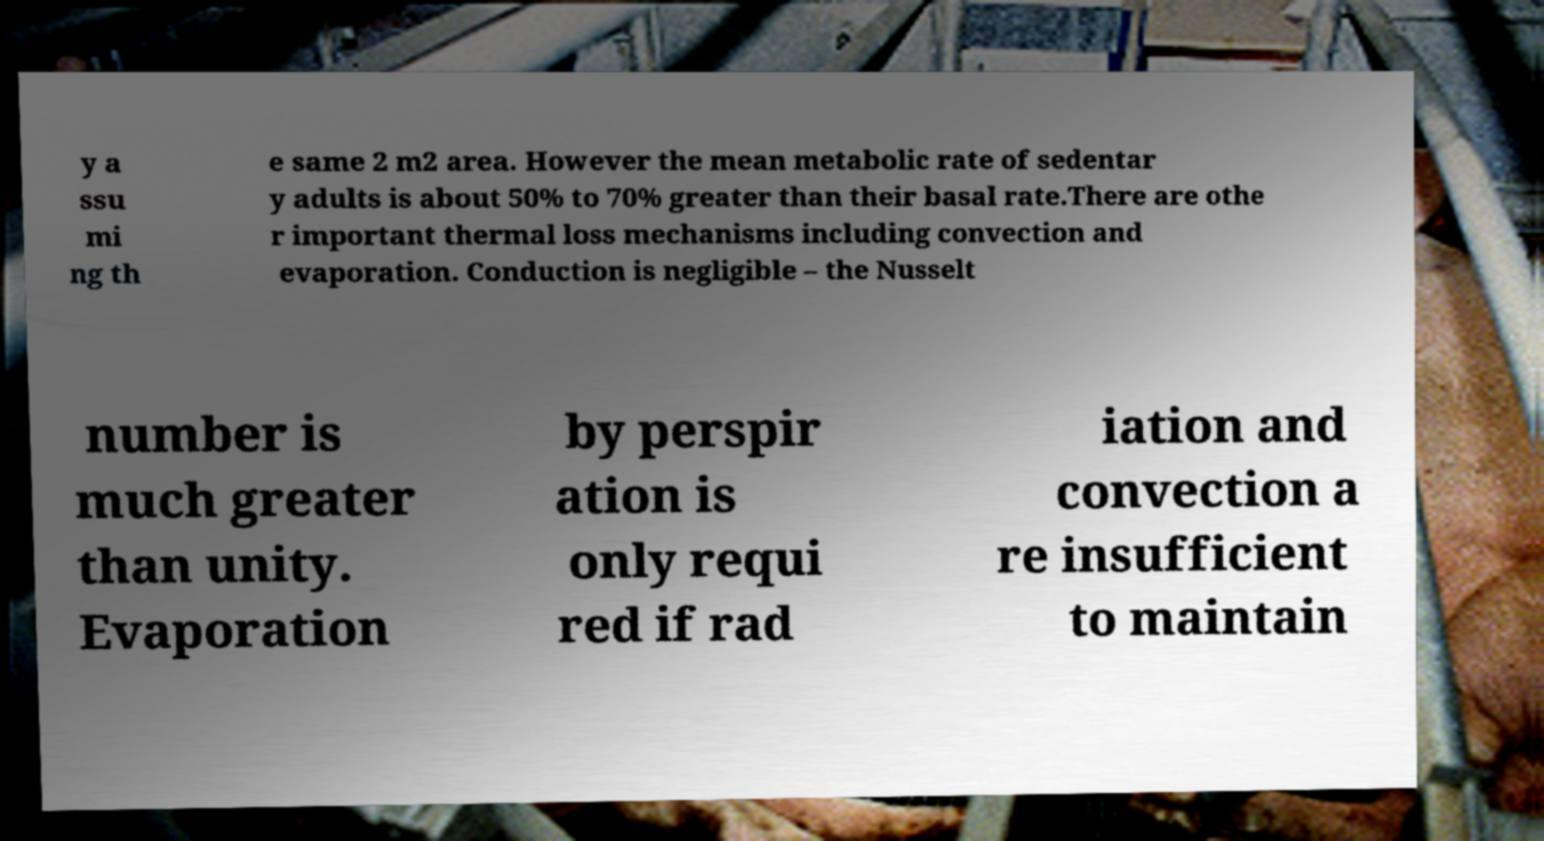Can you accurately transcribe the text from the provided image for me? y a ssu mi ng th e same 2 m2 area. However the mean metabolic rate of sedentar y adults is about 50% to 70% greater than their basal rate.There are othe r important thermal loss mechanisms including convection and evaporation. Conduction is negligible – the Nusselt number is much greater than unity. Evaporation by perspir ation is only requi red if rad iation and convection a re insufficient to maintain 